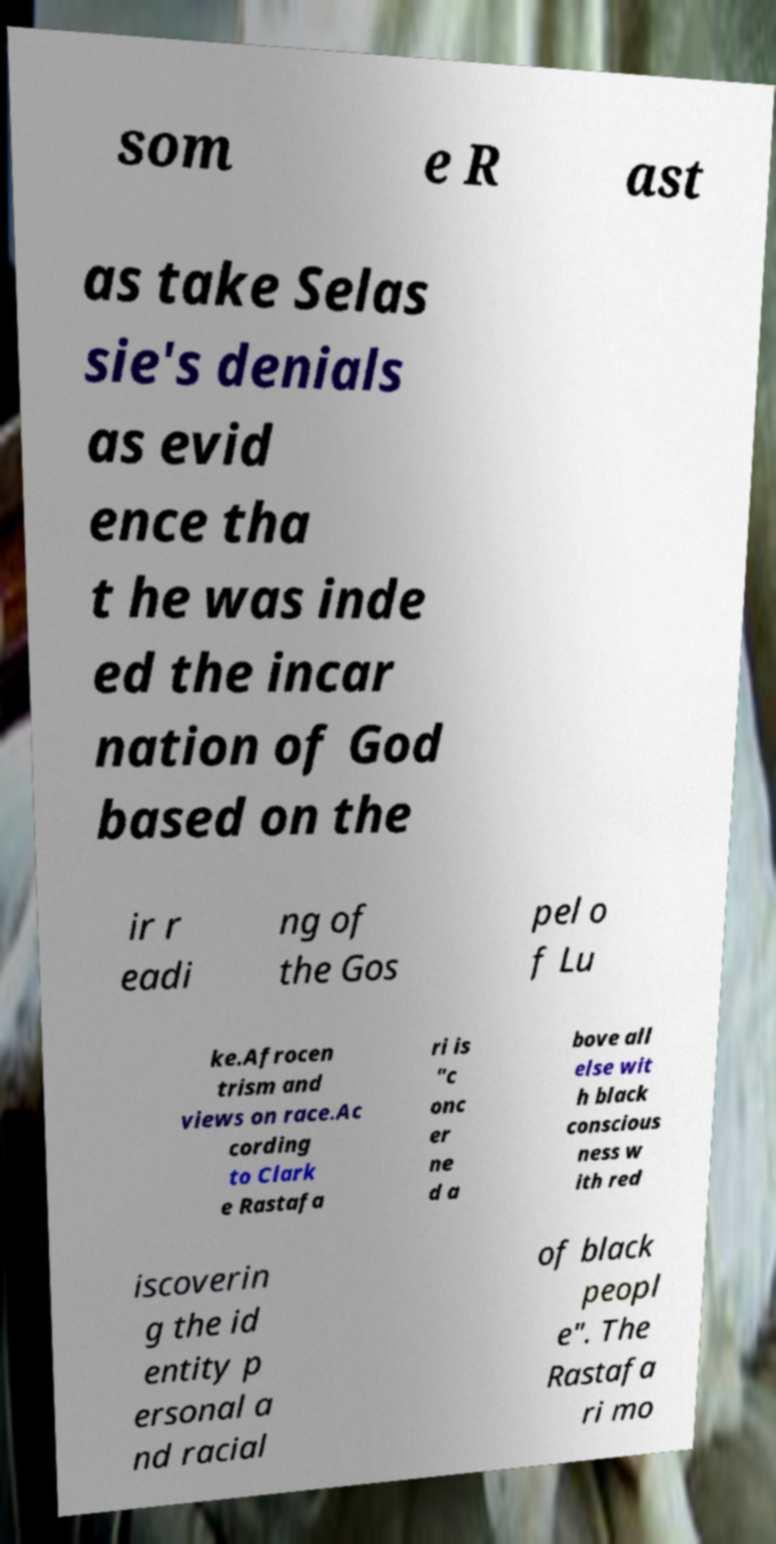Please identify and transcribe the text found in this image. som e R ast as take Selas sie's denials as evid ence tha t he was inde ed the incar nation of God based on the ir r eadi ng of the Gos pel o f Lu ke.Afrocen trism and views on race.Ac cording to Clark e Rastafa ri is "c onc er ne d a bove all else wit h black conscious ness w ith red iscoverin g the id entity p ersonal a nd racial of black peopl e". The Rastafa ri mo 